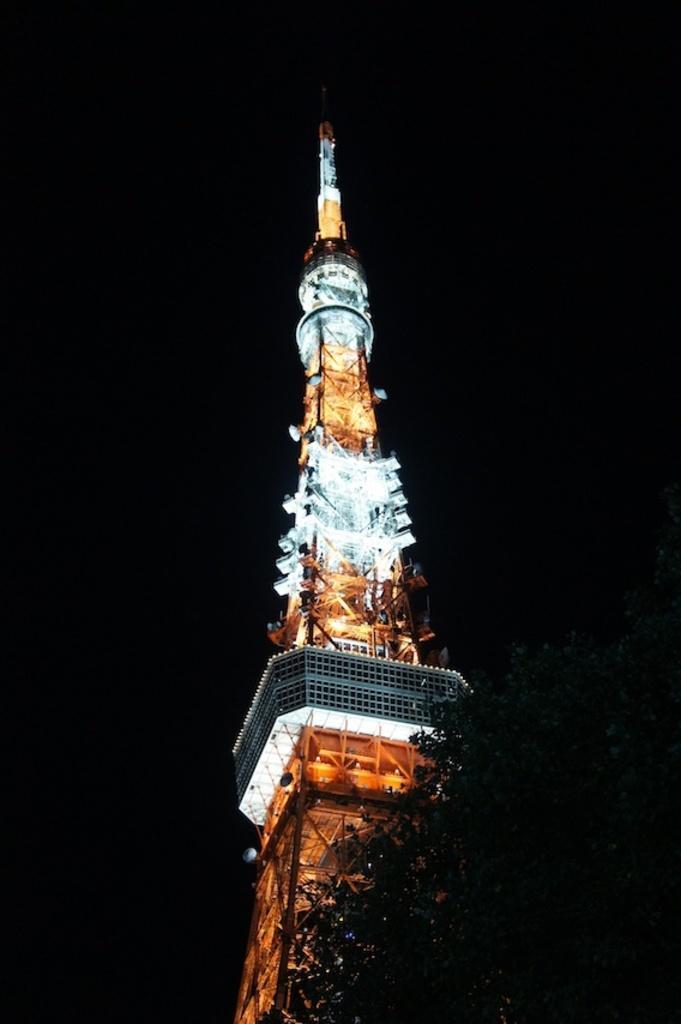Can you describe this image briefly? In this image, we can see a tower and there are some lights, there is a dark background. 